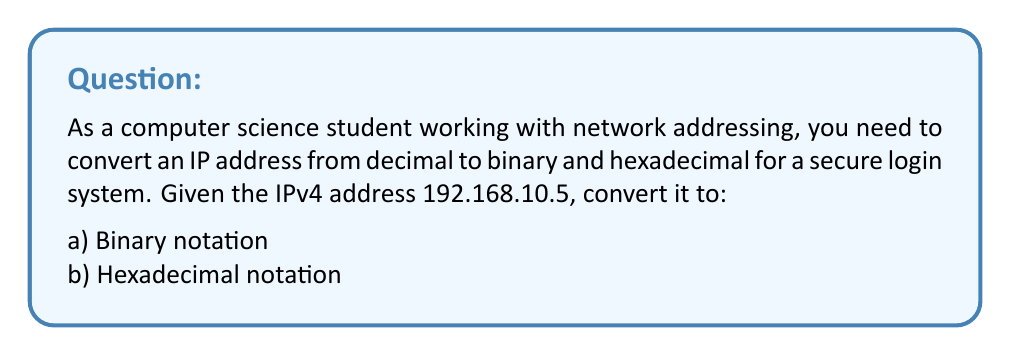Can you answer this question? Let's approach this step-by-step:

1) First, we'll convert each octet of the IP address from decimal to binary:

   192 (decimal) to binary:
   $192 = (128 + 64 + 0 + 0 + 0 + 0 + 0 + 0)_2 = 11000000_2$

   168 (decimal) to binary:
   $168 = (128 + 32 + 8 + 0 + 0 + 0 + 0 + 0)_2 = 10101000_2$

   10 (decimal) to binary:
   $10 = (0 + 0 + 0 + 8 + 2 + 0 + 0 + 0)_2 = 00001010_2$

   5 (decimal) to binary:
   $5 = (0 + 0 + 0 + 0 + 4 + 1 + 0 + 0)_2 = 00000101_2$

2) Now, we combine these binary octets:

   Binary IP: 11000000.10101000.00001010.00000101

3) For the hexadecimal conversion, we can convert each octet separately:

   192 (decimal) to hexadecimal:
   $192 = (12 * 16) + (0 * 1) = C0_{16}$

   168 (decimal) to hexadecimal:
   $168 = (10 * 16) + (8 * 1) = A8_{16}$

   10 (decimal) to hexadecimal:
   $10 = (0 * 16) + (10 * 1) = 0A_{16}$

   5 (decimal) to hexadecimal:
   $5 = (0 * 16) + (5 * 1) = 05_{16}$

4) Combining these hexadecimal octets:

   Hexadecimal IP: C0.A8.0A.05

This conversion process is crucial for network addressing and can be applied in various scenarios, including secure login systems where IP addresses might need to be stored or processed in different formats.
Answer: a) Binary: 11000000.10101000.00001010.00000101
b) Hexadecimal: C0.A8.0A.05 